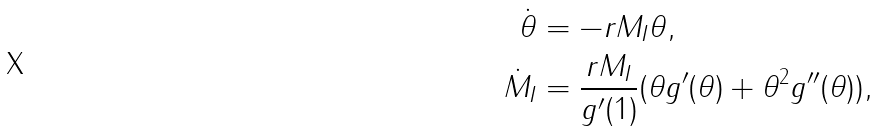<formula> <loc_0><loc_0><loc_500><loc_500>\dot { \theta } & = - r M _ { I } \theta , \\ \dot { M } _ { I } & = \frac { r M _ { I } } { g ^ { \prime } ( 1 ) } ( \theta g ^ { \prime } ( \theta ) + \theta ^ { 2 } g ^ { \prime \prime } ( \theta ) ) ,</formula> 